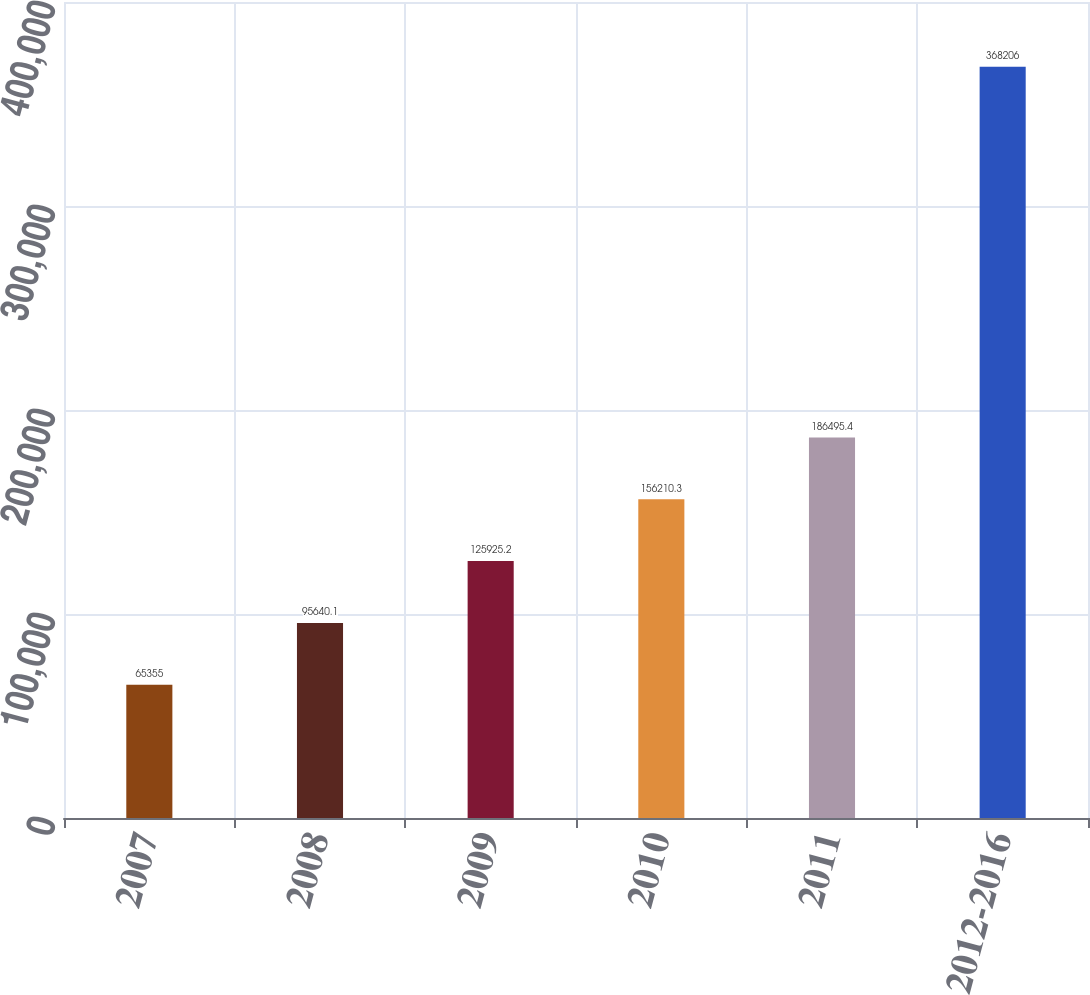Convert chart to OTSL. <chart><loc_0><loc_0><loc_500><loc_500><bar_chart><fcel>2007<fcel>2008<fcel>2009<fcel>2010<fcel>2011<fcel>2012-2016<nl><fcel>65355<fcel>95640.1<fcel>125925<fcel>156210<fcel>186495<fcel>368206<nl></chart> 